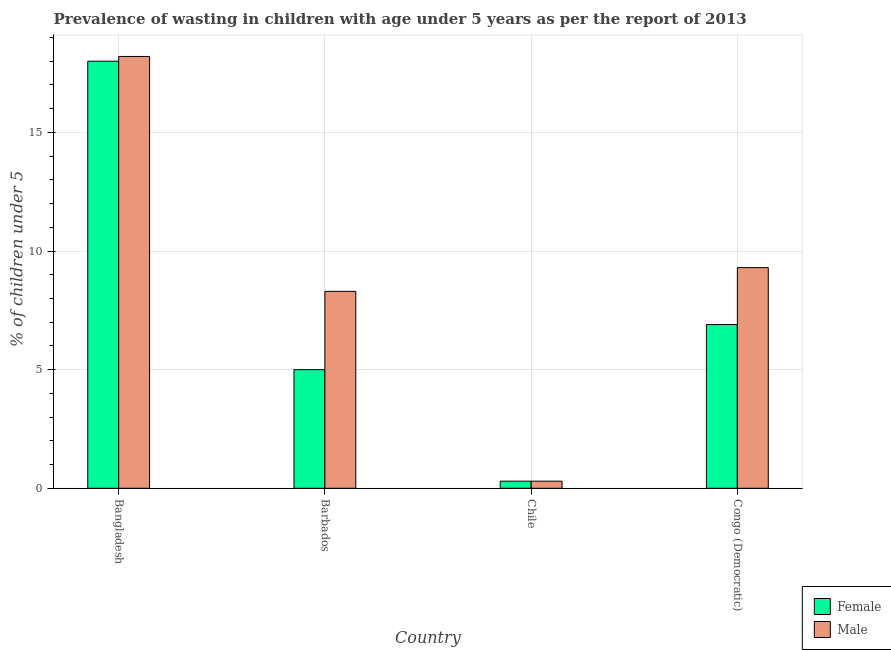How many groups of bars are there?
Your answer should be compact. 4. Are the number of bars per tick equal to the number of legend labels?
Ensure brevity in your answer.  Yes. How many bars are there on the 3rd tick from the left?
Keep it short and to the point. 2. How many bars are there on the 1st tick from the right?
Your answer should be very brief. 2. What is the label of the 2nd group of bars from the left?
Keep it short and to the point. Barbados. What is the percentage of undernourished female children in Congo (Democratic)?
Provide a succinct answer. 6.9. Across all countries, what is the maximum percentage of undernourished female children?
Give a very brief answer. 18. Across all countries, what is the minimum percentage of undernourished female children?
Your answer should be compact. 0.3. In which country was the percentage of undernourished female children minimum?
Offer a terse response. Chile. What is the total percentage of undernourished female children in the graph?
Keep it short and to the point. 30.2. What is the difference between the percentage of undernourished female children in Barbados and that in Chile?
Ensure brevity in your answer.  4.7. What is the difference between the percentage of undernourished female children in Bangladesh and the percentage of undernourished male children in Chile?
Offer a terse response. 17.7. What is the average percentage of undernourished female children per country?
Offer a terse response. 7.55. What is the difference between the percentage of undernourished male children and percentage of undernourished female children in Congo (Democratic)?
Offer a terse response. 2.4. What is the ratio of the percentage of undernourished male children in Bangladesh to that in Chile?
Provide a succinct answer. 60.67. Is the difference between the percentage of undernourished male children in Bangladesh and Chile greater than the difference between the percentage of undernourished female children in Bangladesh and Chile?
Your answer should be very brief. Yes. What is the difference between the highest and the second highest percentage of undernourished male children?
Give a very brief answer. 8.9. What is the difference between the highest and the lowest percentage of undernourished male children?
Offer a terse response. 17.9. Is the sum of the percentage of undernourished female children in Barbados and Chile greater than the maximum percentage of undernourished male children across all countries?
Make the answer very short. No. How many bars are there?
Your response must be concise. 8. How many countries are there in the graph?
Your response must be concise. 4. What is the difference between two consecutive major ticks on the Y-axis?
Your answer should be compact. 5. Are the values on the major ticks of Y-axis written in scientific E-notation?
Keep it short and to the point. No. Does the graph contain grids?
Keep it short and to the point. Yes. Where does the legend appear in the graph?
Provide a short and direct response. Bottom right. What is the title of the graph?
Your answer should be very brief. Prevalence of wasting in children with age under 5 years as per the report of 2013. What is the label or title of the X-axis?
Your answer should be very brief. Country. What is the label or title of the Y-axis?
Offer a very short reply.  % of children under 5. What is the  % of children under 5 in Female in Bangladesh?
Provide a succinct answer. 18. What is the  % of children under 5 in Male in Bangladesh?
Provide a succinct answer. 18.2. What is the  % of children under 5 in Female in Barbados?
Keep it short and to the point. 5. What is the  % of children under 5 in Female in Chile?
Offer a very short reply. 0.3. What is the  % of children under 5 in Male in Chile?
Your answer should be very brief. 0.3. What is the  % of children under 5 of Female in Congo (Democratic)?
Provide a succinct answer. 6.9. What is the  % of children under 5 of Male in Congo (Democratic)?
Your answer should be compact. 9.3. Across all countries, what is the maximum  % of children under 5 in Female?
Your answer should be very brief. 18. Across all countries, what is the maximum  % of children under 5 in Male?
Ensure brevity in your answer.  18.2. Across all countries, what is the minimum  % of children under 5 in Female?
Your answer should be very brief. 0.3. Across all countries, what is the minimum  % of children under 5 in Male?
Provide a succinct answer. 0.3. What is the total  % of children under 5 in Female in the graph?
Your response must be concise. 30.2. What is the total  % of children under 5 in Male in the graph?
Your answer should be compact. 36.1. What is the difference between the  % of children under 5 in Female in Bangladesh and that in Barbados?
Your answer should be compact. 13. What is the difference between the  % of children under 5 of Female in Bangladesh and that in Chile?
Provide a short and direct response. 17.7. What is the difference between the  % of children under 5 in Female in Bangladesh and that in Congo (Democratic)?
Give a very brief answer. 11.1. What is the difference between the  % of children under 5 of Male in Bangladesh and that in Congo (Democratic)?
Ensure brevity in your answer.  8.9. What is the difference between the  % of children under 5 of Male in Barbados and that in Congo (Democratic)?
Offer a terse response. -1. What is the difference between the  % of children under 5 of Male in Chile and that in Congo (Democratic)?
Your answer should be compact. -9. What is the difference between the  % of children under 5 of Female in Bangladesh and the  % of children under 5 of Male in Chile?
Keep it short and to the point. 17.7. What is the difference between the  % of children under 5 of Female in Barbados and the  % of children under 5 of Male in Chile?
Keep it short and to the point. 4.7. What is the difference between the  % of children under 5 in Female in Barbados and the  % of children under 5 in Male in Congo (Democratic)?
Provide a succinct answer. -4.3. What is the difference between the  % of children under 5 in Female in Chile and the  % of children under 5 in Male in Congo (Democratic)?
Keep it short and to the point. -9. What is the average  % of children under 5 of Female per country?
Provide a short and direct response. 7.55. What is the average  % of children under 5 of Male per country?
Your response must be concise. 9.03. What is the difference between the  % of children under 5 of Female and  % of children under 5 of Male in Congo (Democratic)?
Keep it short and to the point. -2.4. What is the ratio of the  % of children under 5 in Female in Bangladesh to that in Barbados?
Ensure brevity in your answer.  3.6. What is the ratio of the  % of children under 5 of Male in Bangladesh to that in Barbados?
Make the answer very short. 2.19. What is the ratio of the  % of children under 5 of Female in Bangladesh to that in Chile?
Keep it short and to the point. 60. What is the ratio of the  % of children under 5 in Male in Bangladesh to that in Chile?
Your response must be concise. 60.67. What is the ratio of the  % of children under 5 in Female in Bangladesh to that in Congo (Democratic)?
Offer a terse response. 2.61. What is the ratio of the  % of children under 5 of Male in Bangladesh to that in Congo (Democratic)?
Keep it short and to the point. 1.96. What is the ratio of the  % of children under 5 of Female in Barbados to that in Chile?
Keep it short and to the point. 16.67. What is the ratio of the  % of children under 5 in Male in Barbados to that in Chile?
Your answer should be very brief. 27.67. What is the ratio of the  % of children under 5 in Female in Barbados to that in Congo (Democratic)?
Ensure brevity in your answer.  0.72. What is the ratio of the  % of children under 5 of Male in Barbados to that in Congo (Democratic)?
Provide a succinct answer. 0.89. What is the ratio of the  % of children under 5 in Female in Chile to that in Congo (Democratic)?
Give a very brief answer. 0.04. What is the ratio of the  % of children under 5 of Male in Chile to that in Congo (Democratic)?
Ensure brevity in your answer.  0.03. What is the difference between the highest and the lowest  % of children under 5 in Female?
Offer a terse response. 17.7. 